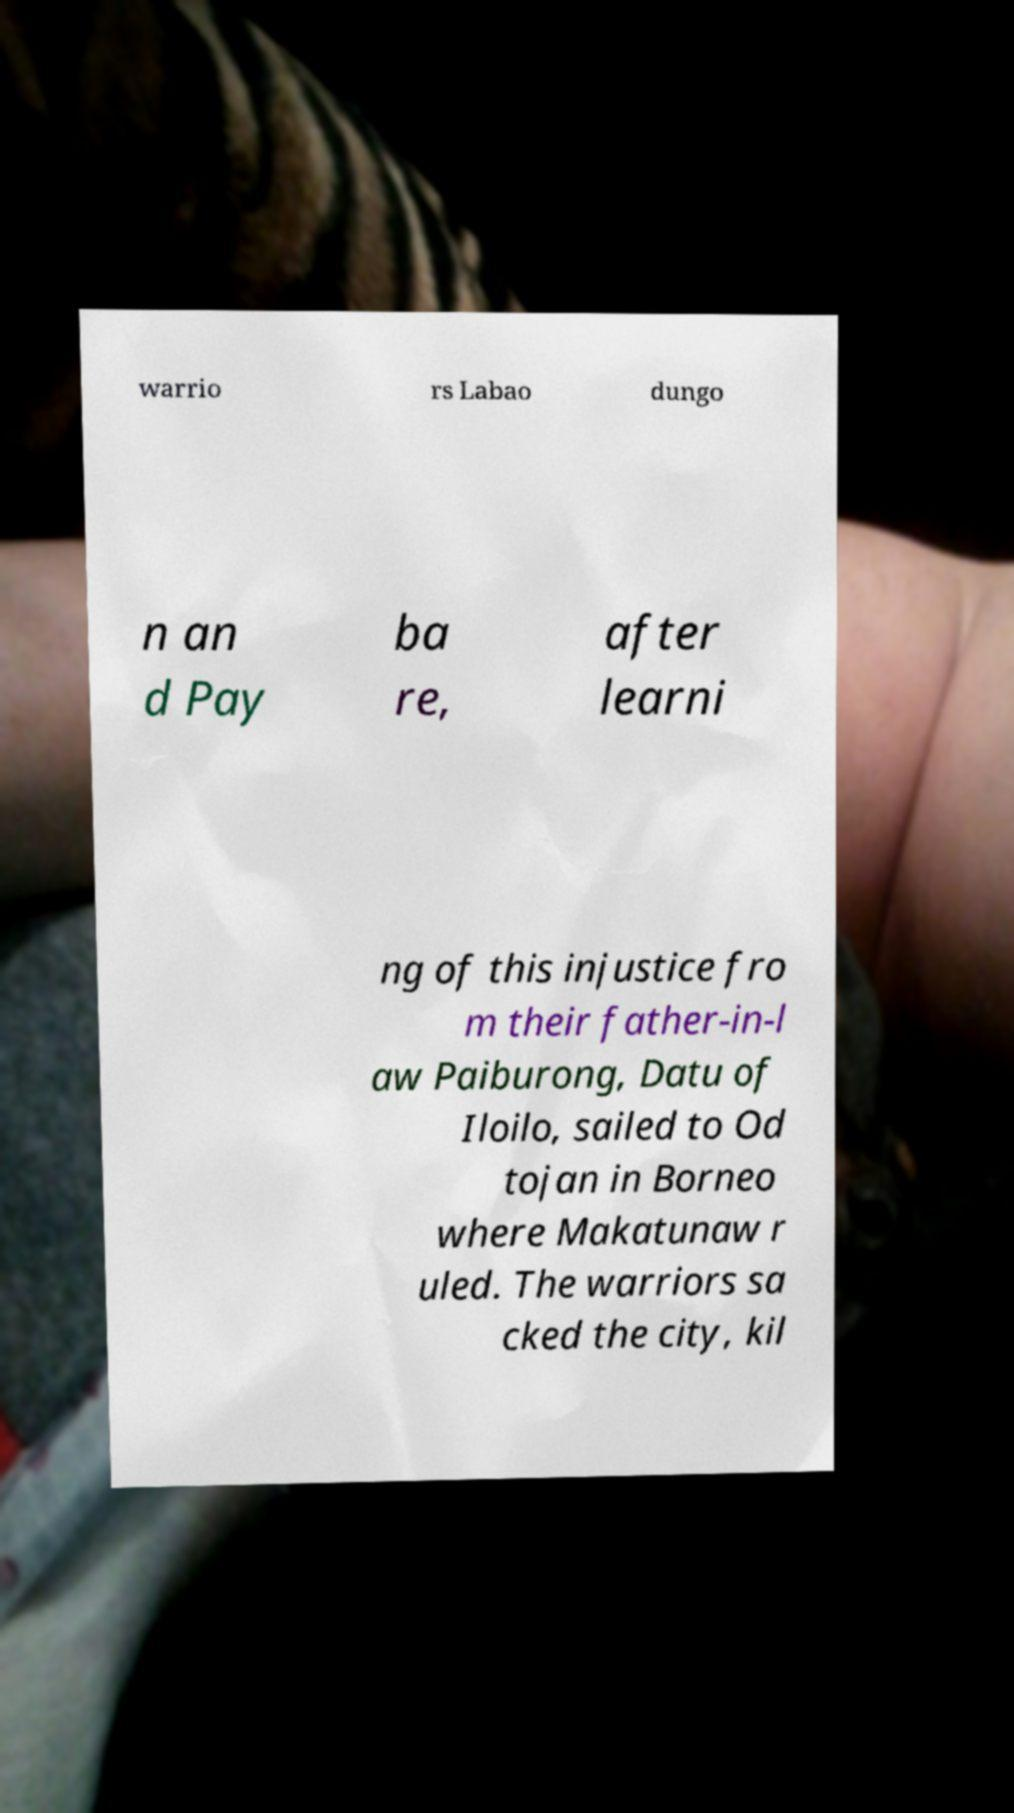Please identify and transcribe the text found in this image. warrio rs Labao dungo n an d Pay ba re, after learni ng of this injustice fro m their father-in-l aw Paiburong, Datu of Iloilo, sailed to Od tojan in Borneo where Makatunaw r uled. The warriors sa cked the city, kil 